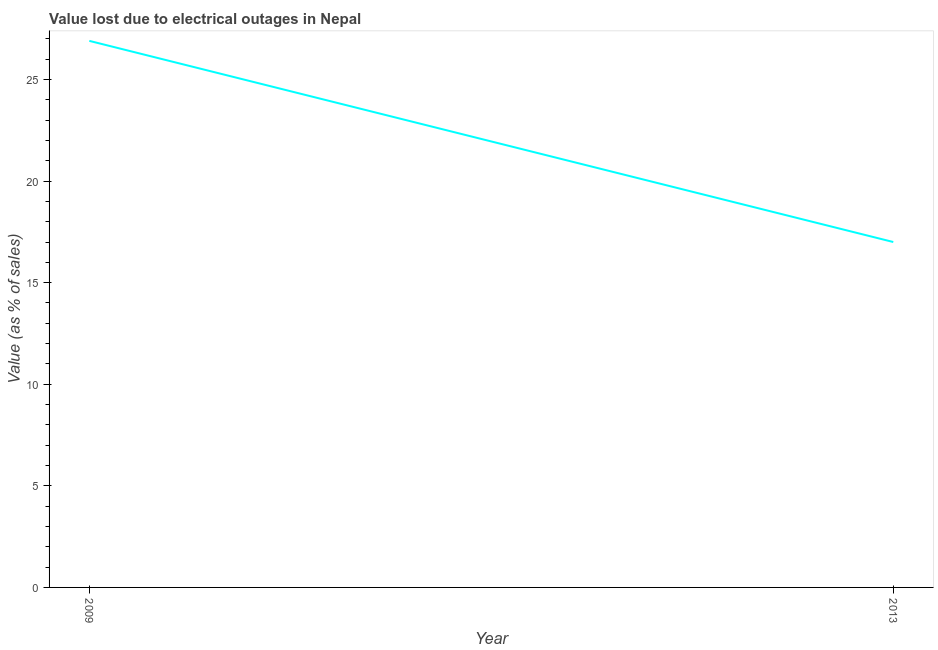Across all years, what is the maximum value lost due to electrical outages?
Your answer should be very brief. 26.9. In which year was the value lost due to electrical outages maximum?
Provide a short and direct response. 2009. What is the sum of the value lost due to electrical outages?
Offer a terse response. 43.9. What is the difference between the value lost due to electrical outages in 2009 and 2013?
Give a very brief answer. 9.9. What is the average value lost due to electrical outages per year?
Offer a very short reply. 21.95. What is the median value lost due to electrical outages?
Keep it short and to the point. 21.95. In how many years, is the value lost due to electrical outages greater than 7 %?
Make the answer very short. 2. What is the ratio of the value lost due to electrical outages in 2009 to that in 2013?
Provide a succinct answer. 1.58. Is the value lost due to electrical outages in 2009 less than that in 2013?
Provide a short and direct response. No. In how many years, is the value lost due to electrical outages greater than the average value lost due to electrical outages taken over all years?
Ensure brevity in your answer.  1. Does the value lost due to electrical outages monotonically increase over the years?
Your answer should be compact. No. How many years are there in the graph?
Provide a succinct answer. 2. Are the values on the major ticks of Y-axis written in scientific E-notation?
Keep it short and to the point. No. Does the graph contain grids?
Your answer should be very brief. No. What is the title of the graph?
Keep it short and to the point. Value lost due to electrical outages in Nepal. What is the label or title of the X-axis?
Offer a very short reply. Year. What is the label or title of the Y-axis?
Provide a succinct answer. Value (as % of sales). What is the Value (as % of sales) of 2009?
Ensure brevity in your answer.  26.9. What is the Value (as % of sales) of 2013?
Provide a succinct answer. 17. What is the ratio of the Value (as % of sales) in 2009 to that in 2013?
Provide a succinct answer. 1.58. 